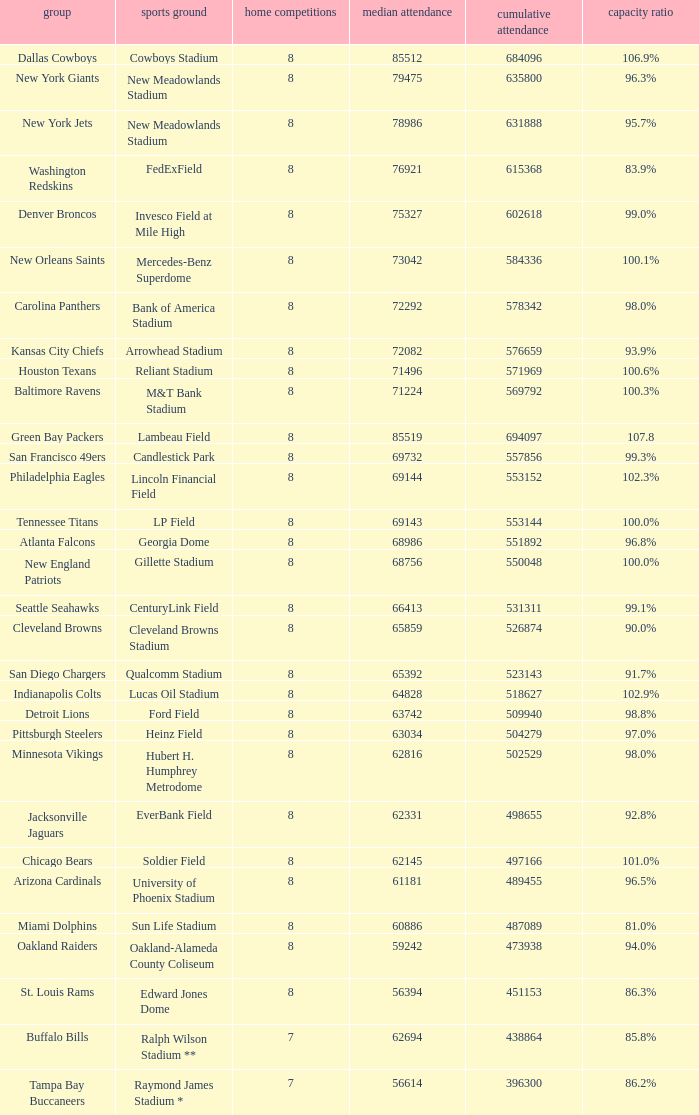What is the capacity percentage when the total attendance is 509940? 98.8%. 